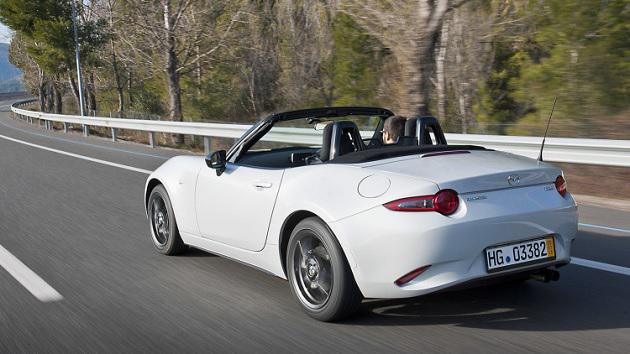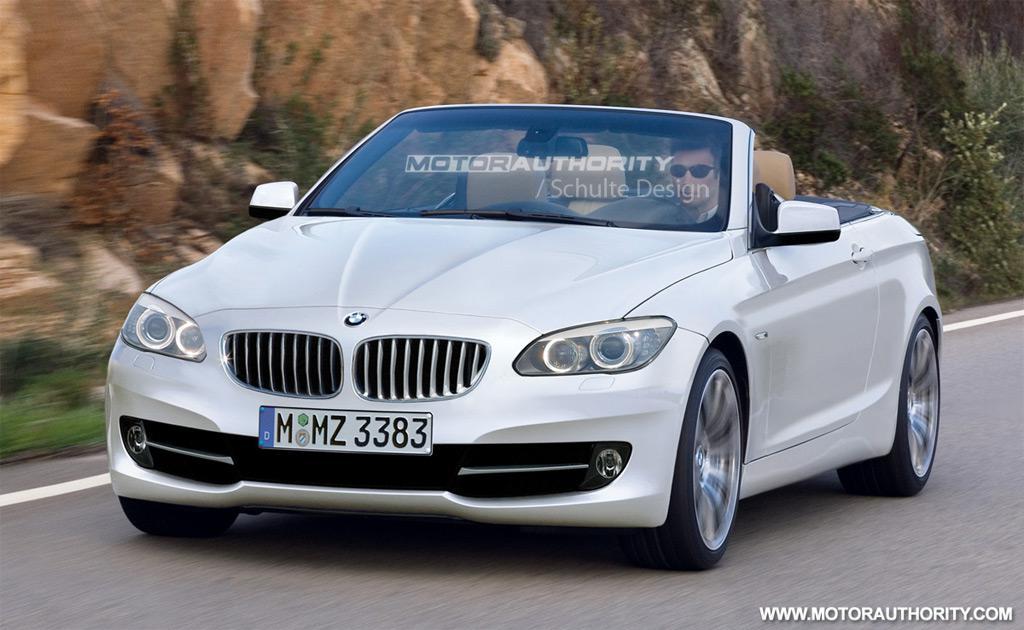The first image is the image on the left, the second image is the image on the right. Evaluate the accuracy of this statement regarding the images: "The image on the left features a white convertible.". Is it true? Answer yes or no. Yes. The first image is the image on the left, the second image is the image on the right. Assess this claim about the two images: "All the cars are white.". Correct or not? Answer yes or no. Yes. 